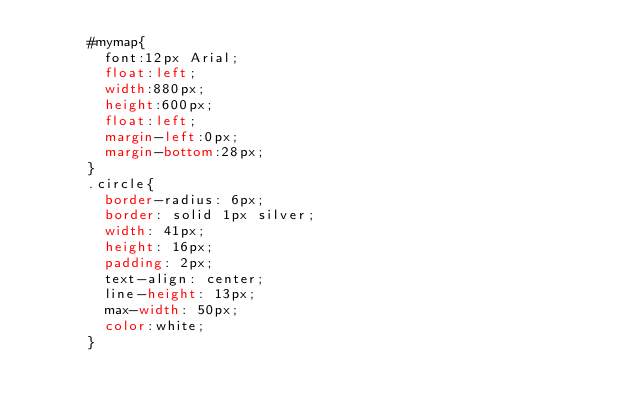<code> <loc_0><loc_0><loc_500><loc_500><_CSS_>      #mymap{
        font:12px Arial;
        float:left;
        width:880px;
        height:600px;
        float:left;
        margin-left:0px;
        margin-bottom:28px;
      }
      .circle{
      	border-radius: 6px;
      	border: solid 1px silver;
       	width: 41px;
       	height: 16px;
       	padding: 2px;
       	text-align: center;
      	line-height: 13px;
      	max-width: 50px;
        color:white;
      }</code> 